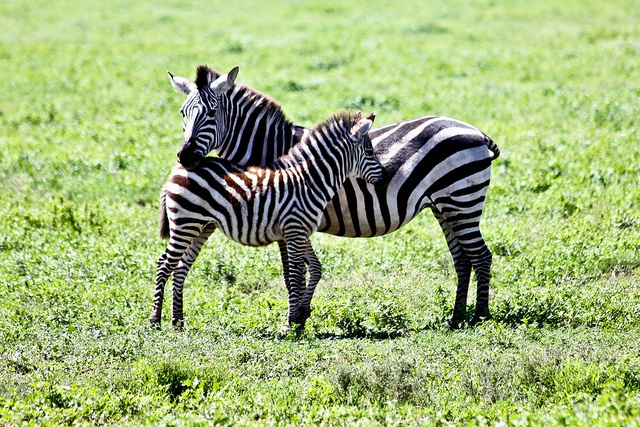Describe the objects in this image and their specific colors. I can see zebra in lightgreen, black, darkgray, gray, and white tones and zebra in lightgreen, black, darkgray, gray, and white tones in this image. 